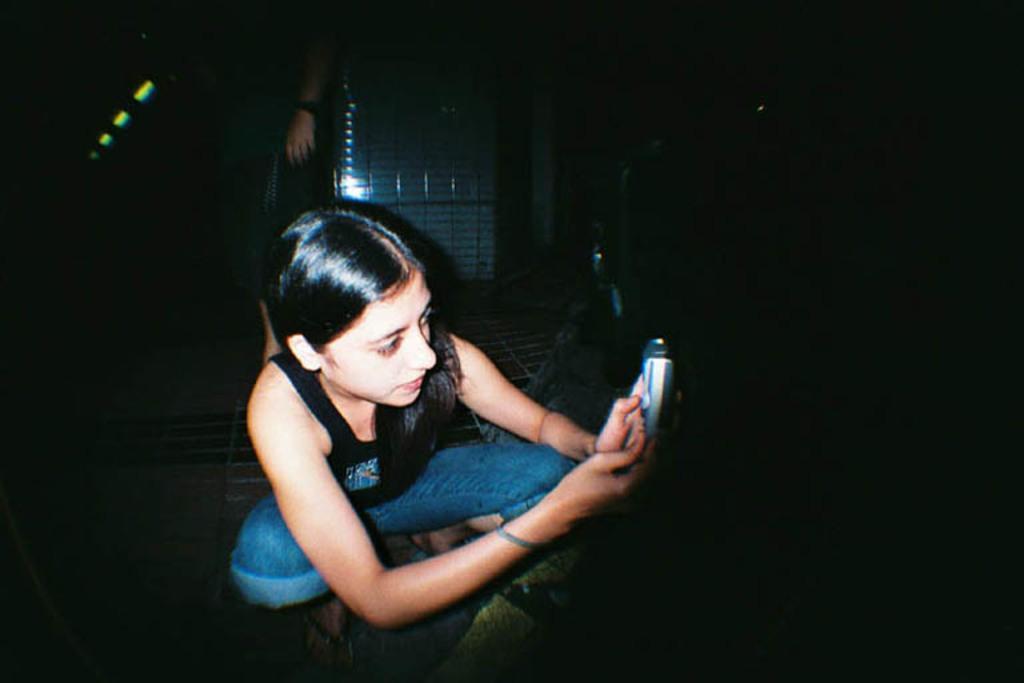Please provide a concise description of this image. In the center of the image we can see a lady is sitting on her knees and holding a mobile. In the background of the image we can see the person, person hand and object. On the right side the image is dark. 